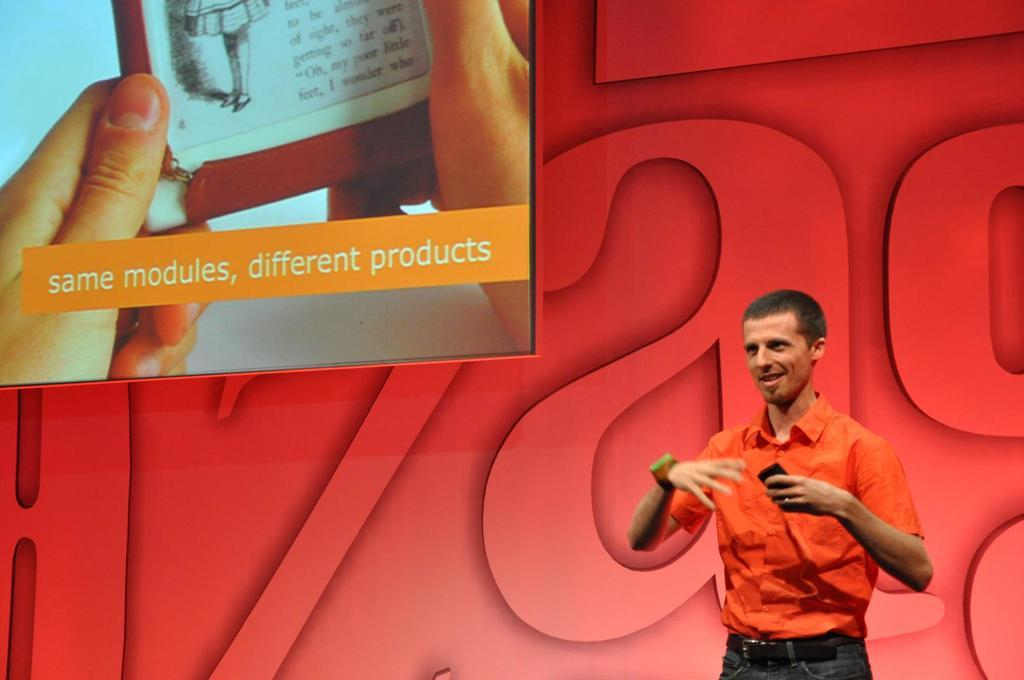Provide a one-sentence caption for the provided image. Man in an orange shirt with a photo about the same modules just a different product. 